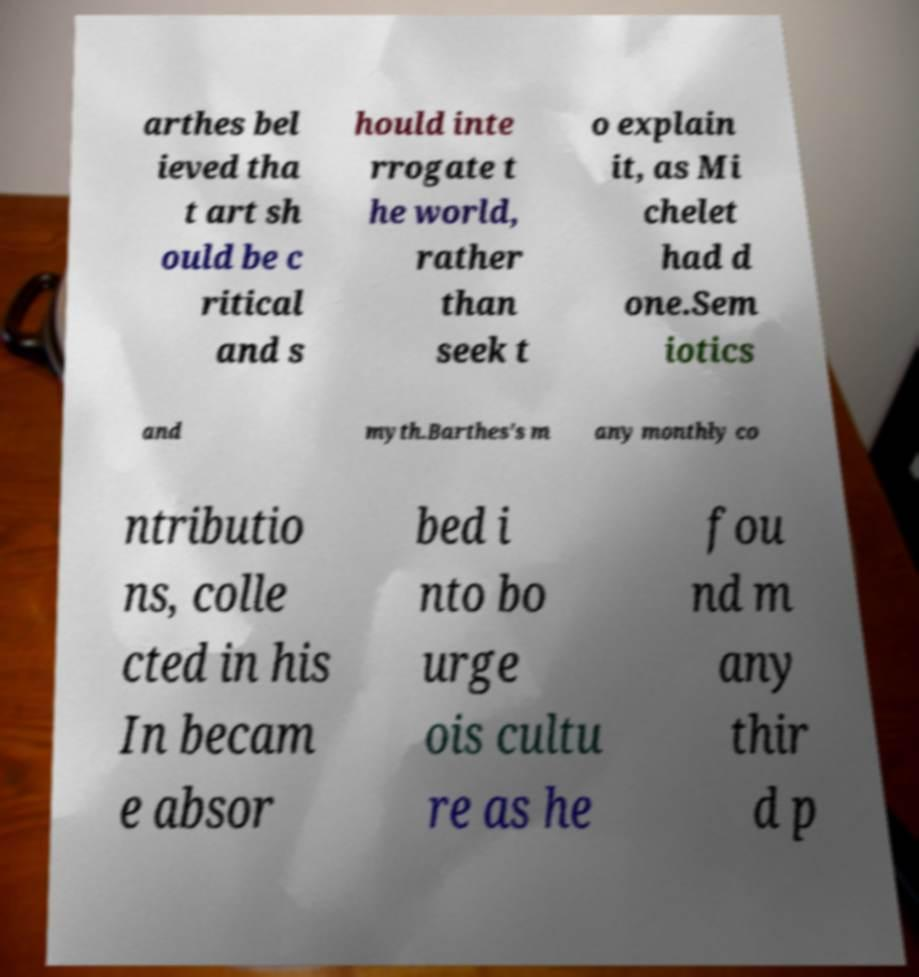For documentation purposes, I need the text within this image transcribed. Could you provide that? arthes bel ieved tha t art sh ould be c ritical and s hould inte rrogate t he world, rather than seek t o explain it, as Mi chelet had d one.Sem iotics and myth.Barthes's m any monthly co ntributio ns, colle cted in his In becam e absor bed i nto bo urge ois cultu re as he fou nd m any thir d p 